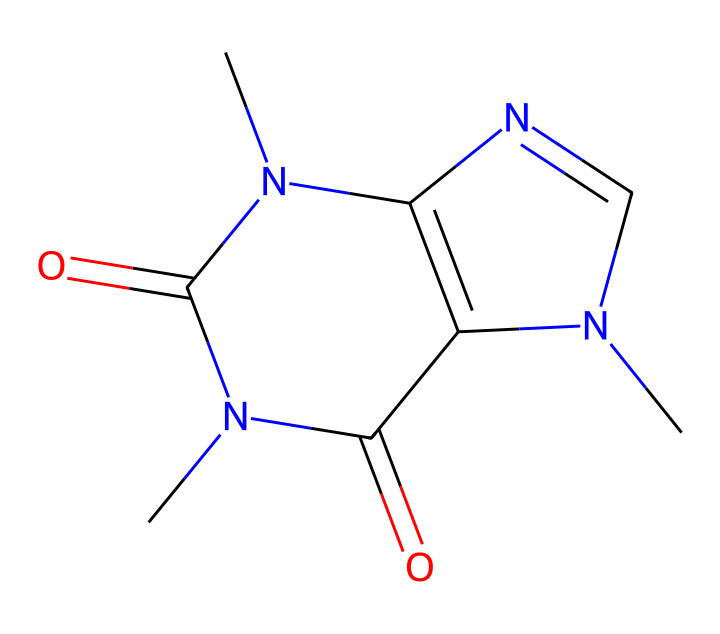What is the molecular formula of caffeine? To determine the molecular formula, count the number of each type of atom in the SMILES representation. In the provided SMILES, there are 8 carbon (C), 10 hydrogen (H), 4 nitrogen (N), and 2 oxygen (O) atoms. This gives us the formula C8H10N4O2.
Answer: C8H10N4O2 How many nitrogen atoms are in caffeine? From the SMILES representation, we can count the nitrogen atoms present in the structure. There are 4 nitrogen atoms indicated by the letter "N" in the SMILES.
Answer: 4 What type of chemical is caffeine? Caffeine is classified as an alkaloid, which is a type of nitrogen-containing organic compound. The presence of multiple nitrogen atoms supports this classification.
Answer: alkaloid Does caffeine have any double bonds? By analyzing the SMILES representation, we can look for double bonds indicated by the "=" symbol. There are double bonds connecting the carbon and nitrogen atoms as well as between carbon and oxygen atoms, confirming the presence of double bonds.
Answer: yes What is the effect of caffeine on the human body? Caffeine is a stimulant that affects the central nervous system. It increases alertness and can enhance mood, which is a well-known characteristic of caffeine consumption.
Answer: stimulant How many rings are present in the caffeine molecule? The SMILES structure reveals two interconnected ring systems; after examining the connections, we find that there are two rings in total.
Answer: 2 What functional groups does caffeine contain? Upon revisiting the SMILES structure, we can identify functional groups such as amines (-NH) and carbonyls (C=O). These are characteristic of the caffeine structure.
Answer: amines and carbonyls 